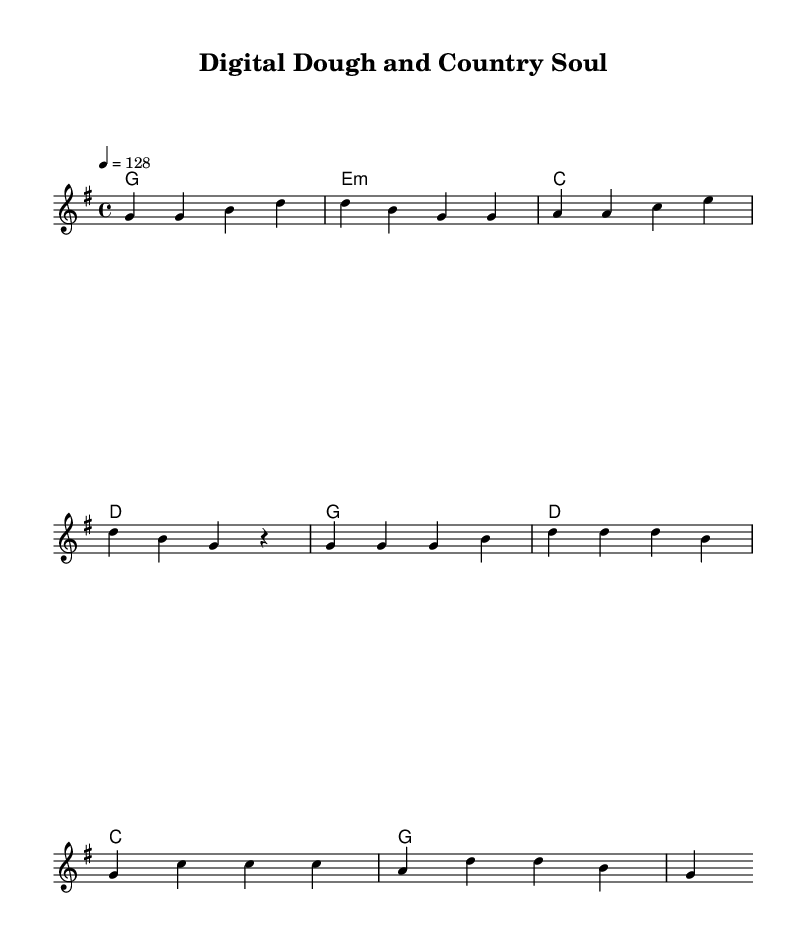What is the key signature of this music? The key signature is indicated by the number of sharps or flats at the beginning of the staff. In this case, it shows one sharp, which signifies that it is in G major.
Answer: G major What is the time signature of this music? The time signature is written as a fraction at the beginning of the staff. Here, it is shown as 4 over 4, meaning there are four beats per measure and a quarter note receives one beat.
Answer: 4/4 What is the tempo marking for this piece? The tempo marking is indicated above the staff and shows the speed of the music. In this instance, it says "4 = 128," which means there are 128 beats per minute.
Answer: 128 How many measures are in the verse? By counting the individual segments or bars within the verse section, there are a total of four distinct measures.
Answer: 4 What are the first two chords of the verse? The chords in the verse are indicated above the melody line. The first two are G major and E minor, as represented at the beginning of the verse section.
Answer: G, E minor What is the primary theme of the lyrics? Analyzing the lyrics provided suggests the theme is about blending old traditions with new technology in daily work. The words focus on baking and using modern tools.
Answer: Blending tradition with technology What is the mood portrayed by the chorus? The lyrics and the upbeat tempo give a celebratory feeling, indicating that the mood is positive and uplifting as it discusses harmony between country roots and modern aspirations.
Answer: Upbeat and celebratory 